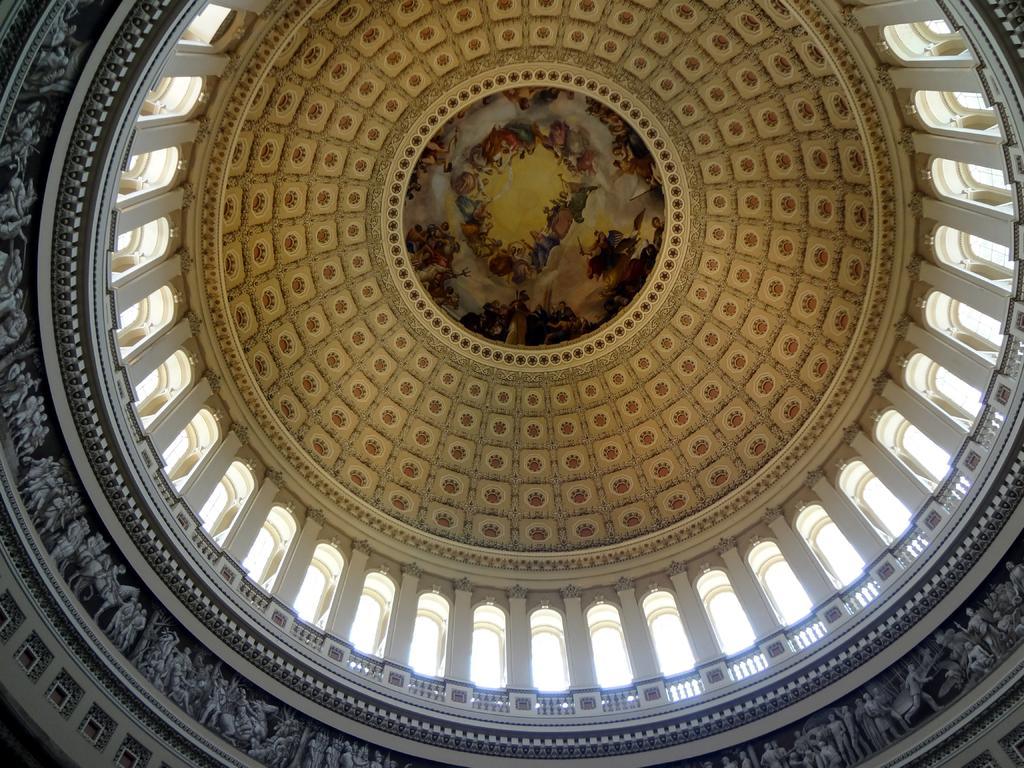What type of structure is shown in the image? The image shows the inner view of a building. What is unique about the building's structure? The building has a dome-like structure. What decorative elements can be seen on the walls of the building? There are sculptures on the walls of the building. What can be found on the ceiling of the building? The ceiling of the building has paintings. What type of need is being fulfilled by the kitten in the image? There is no kitten present in the image. Is the building in the image a church? The provided facts do not mention the building being a church, so we cannot definitively answer that question. 